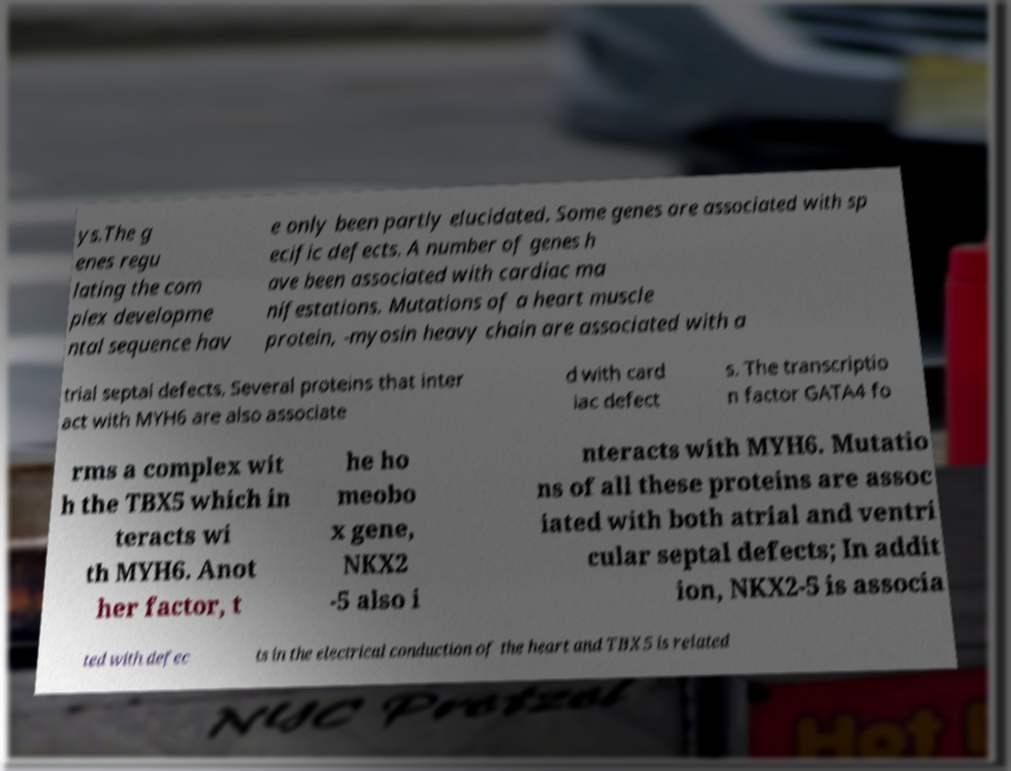Please identify and transcribe the text found in this image. ys.The g enes regu lating the com plex developme ntal sequence hav e only been partly elucidated. Some genes are associated with sp ecific defects. A number of genes h ave been associated with cardiac ma nifestations. Mutations of a heart muscle protein, -myosin heavy chain are associated with a trial septal defects. Several proteins that inter act with MYH6 are also associate d with card iac defect s. The transcriptio n factor GATA4 fo rms a complex wit h the TBX5 which in teracts wi th MYH6. Anot her factor, t he ho meobo x gene, NKX2 -5 also i nteracts with MYH6. Mutatio ns of all these proteins are assoc iated with both atrial and ventri cular septal defects; In addit ion, NKX2-5 is associa ted with defec ts in the electrical conduction of the heart and TBX5 is related 